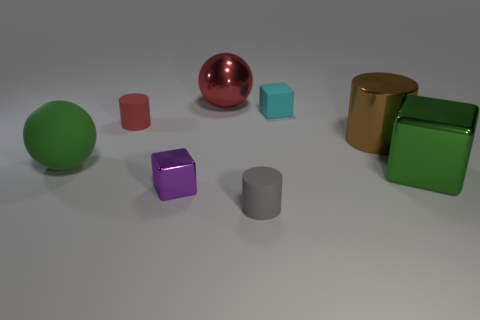What is the small red thing made of?
Your answer should be compact. Rubber. Do the gray cylinder and the cube that is right of the big cylinder have the same material?
Ensure brevity in your answer.  No. The large sphere behind the large sphere in front of the small red thing is what color?
Give a very brief answer. Red. What size is the rubber object that is in front of the red matte thing and right of the red ball?
Provide a succinct answer. Small. How many other objects are the same shape as the big brown object?
Offer a terse response. 2. Is the shape of the big brown thing the same as the tiny rubber object left of the large red ball?
Provide a succinct answer. Yes. There is a big red ball; how many small red matte objects are behind it?
Keep it short and to the point. 0. Is there any other thing that is the same material as the red ball?
Your answer should be compact. Yes. There is a large thing that is in front of the large rubber object; is its shape the same as the purple metallic object?
Your response must be concise. Yes. The rubber sphere on the left side of the cyan matte thing is what color?
Your answer should be compact. Green. 